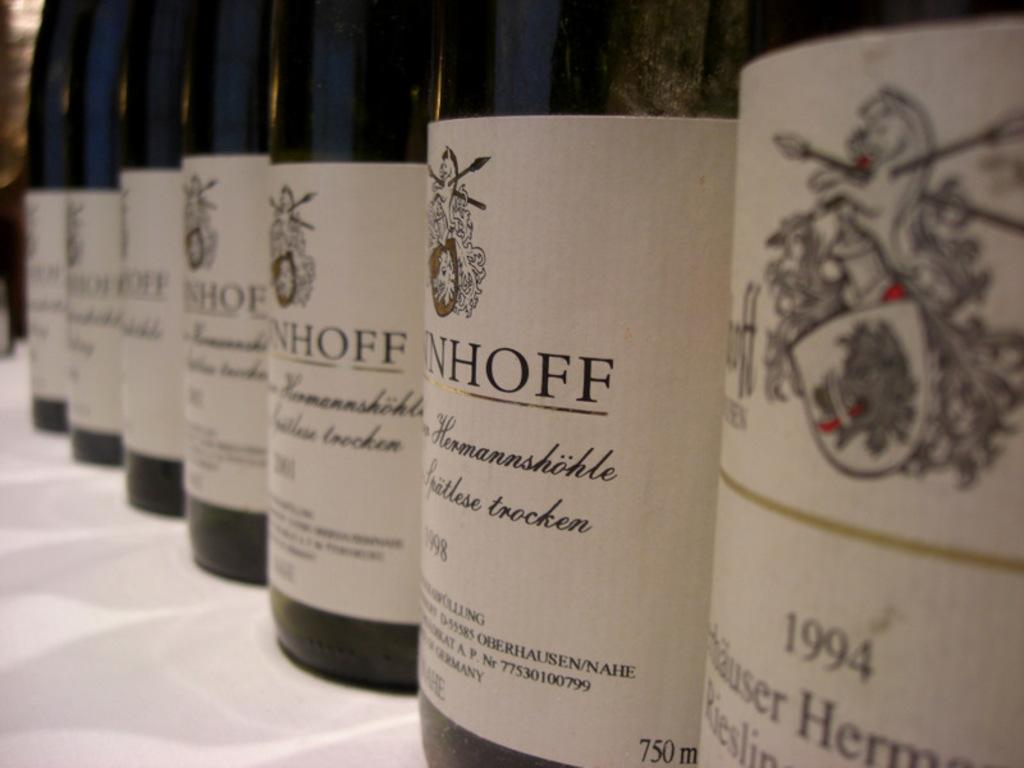<image>
Offer a succinct explanation of the picture presented. A line of several bottles of 750 milliliter wine with a horse crest on the label bottled from 1994 upwards through 2001. 